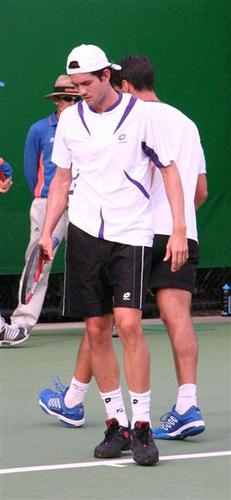What color shorts are the two men wearing?
Quick response, please. Black. What color hat is the man with blue shoes wearing?
Keep it brief. None. What is the man holding?
Answer briefly. Tennis racket. 